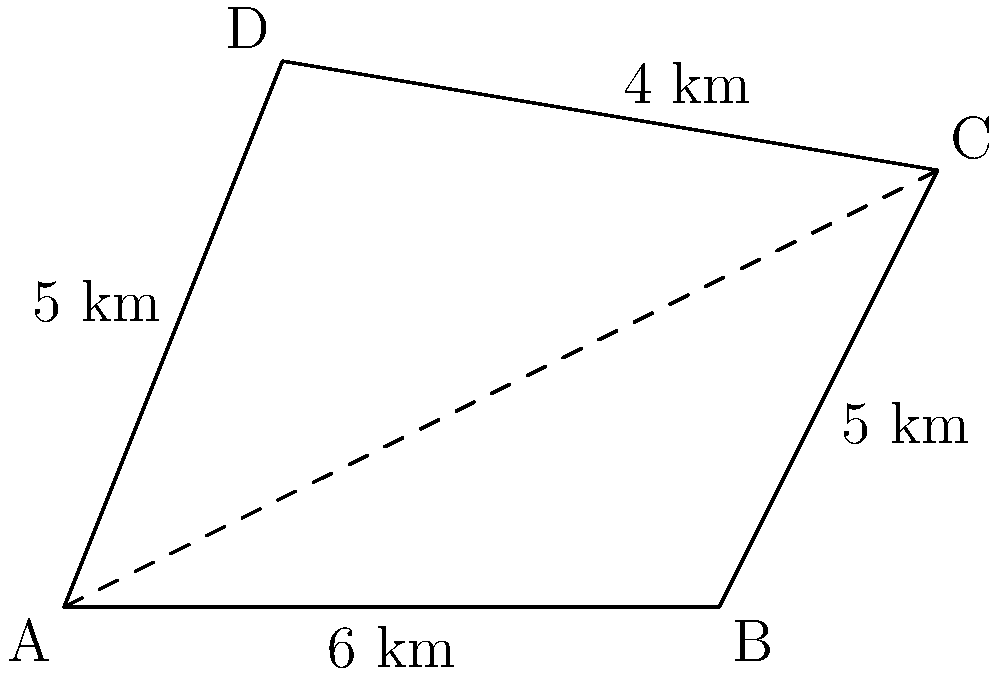A farmer in Khuzestan province has an irregularly shaped plot of land represented by the quadrilateral ABCD. The dimensions are as follows: AB = 6 km, BC = 5 km, CD = 4 km, and DA = 5 km. If the diagonal AC divides the quadrilateral into two triangles with areas 12 km² and 18 km², what is the total area of the plot? To solve this problem, we'll follow these steps:

1) The quadrilateral ABCD is divided into two triangles by the diagonal AC.

2) We are given that these triangles have areas of 12 km² and 18 km².

3) The total area of the quadrilateral will be the sum of these two triangles.

4) Therefore, the area of quadrilateral ABCD is:

   $Area_{ABCD} = Area_{triangle1} + Area_{triangle2}$
   
   $Area_{ABCD} = 12 \text{ km}^2 + 18 \text{ km}^2$
   
   $Area_{ABCD} = 30 \text{ km}^2$

5) We can verify this using the given side lengths, but it's not necessary for answering the question.

Thus, the total area of the farmer's plot is 30 square kilometers.
Answer: 30 km² 